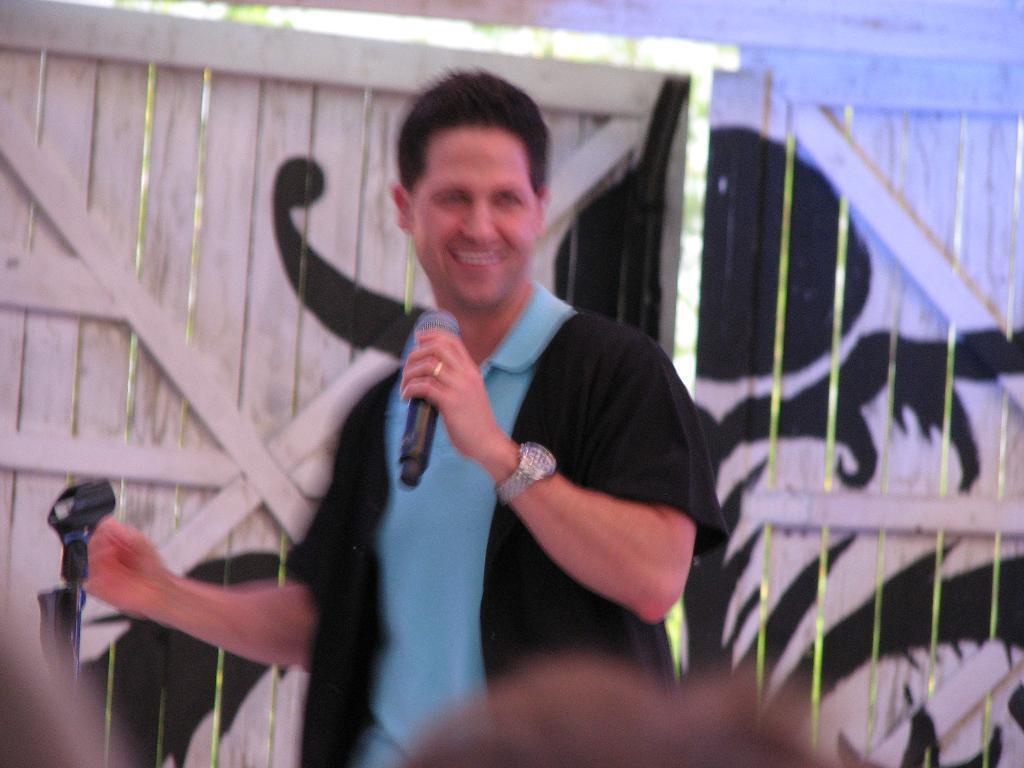Could you give a brief overview of what you see in this image? In the middle a man is standing and also holding a microphone in his left hand. He is smiling, he wore a blue color t-shirt, behind him there is a wooden door. 